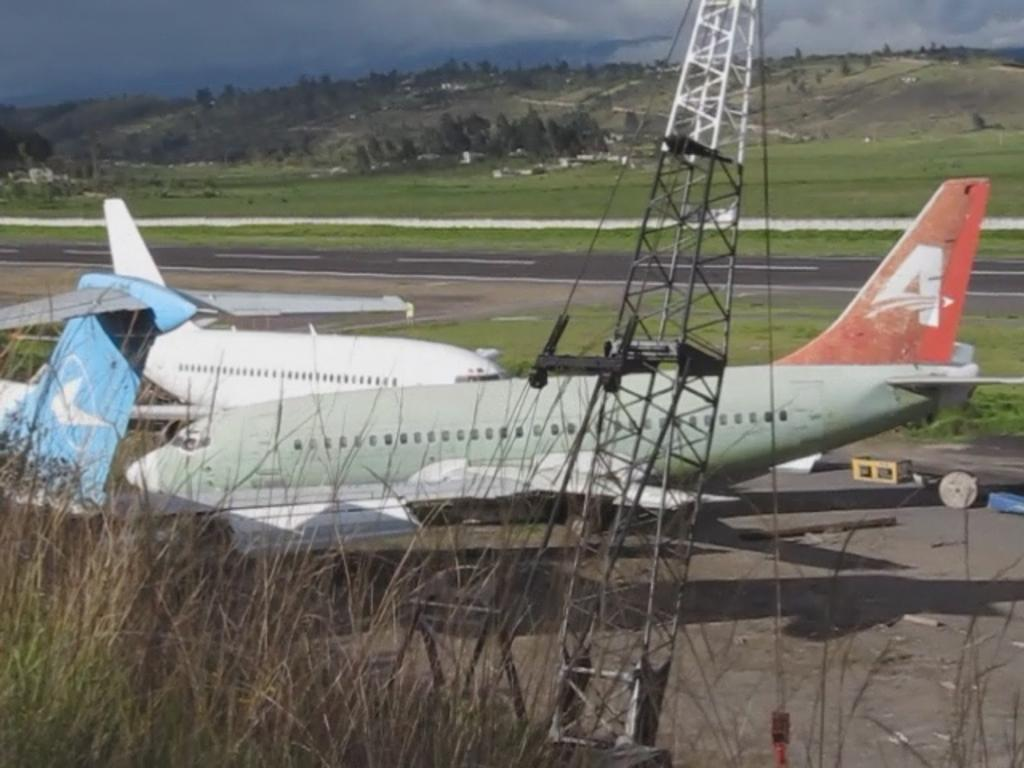<image>
Present a compact description of the photo's key features. An old green aeroplane with a red tail and the letter A on it 